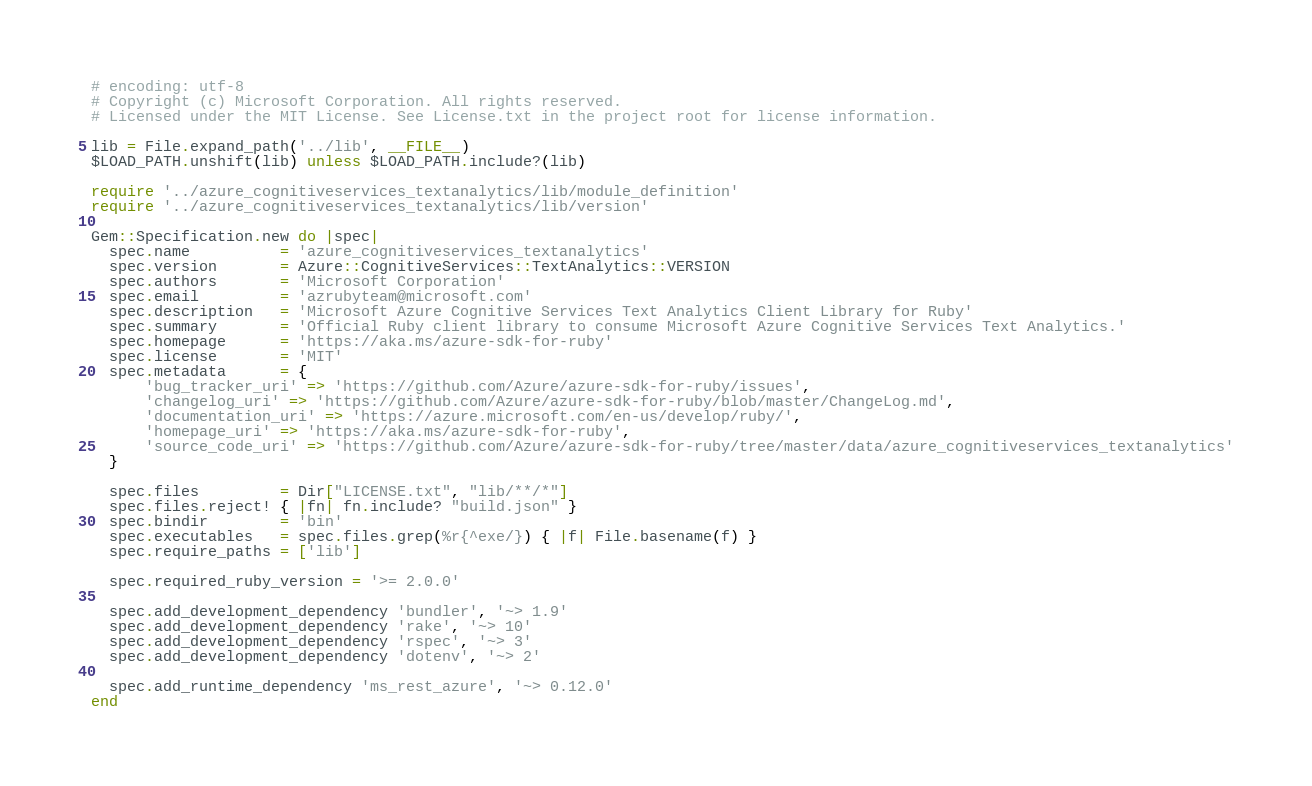Convert code to text. <code><loc_0><loc_0><loc_500><loc_500><_Ruby_># encoding: utf-8
# Copyright (c) Microsoft Corporation. All rights reserved.
# Licensed under the MIT License. See License.txt in the project root for license information.

lib = File.expand_path('../lib', __FILE__)
$LOAD_PATH.unshift(lib) unless $LOAD_PATH.include?(lib)

require '../azure_cognitiveservices_textanalytics/lib/module_definition'
require '../azure_cognitiveservices_textanalytics/lib/version'

Gem::Specification.new do |spec|
  spec.name          = 'azure_cognitiveservices_textanalytics'
  spec.version       = Azure::CognitiveServices::TextAnalytics::VERSION
  spec.authors       = 'Microsoft Corporation'
  spec.email         = 'azrubyteam@microsoft.com'
  spec.description   = 'Microsoft Azure Cognitive Services Text Analytics Client Library for Ruby'
  spec.summary       = 'Official Ruby client library to consume Microsoft Azure Cognitive Services Text Analytics.'
  spec.homepage      = 'https://aka.ms/azure-sdk-for-ruby'
  spec.license       = 'MIT'
  spec.metadata      = {
      'bug_tracker_uri' => 'https://github.com/Azure/azure-sdk-for-ruby/issues',
      'changelog_uri' => 'https://github.com/Azure/azure-sdk-for-ruby/blob/master/ChangeLog.md',
      'documentation_uri' => 'https://azure.microsoft.com/en-us/develop/ruby/',
      'homepage_uri' => 'https://aka.ms/azure-sdk-for-ruby',
      'source_code_uri' => 'https://github.com/Azure/azure-sdk-for-ruby/tree/master/data/azure_cognitiveservices_textanalytics'
  }

  spec.files         = Dir["LICENSE.txt", "lib/**/*"]
  spec.files.reject! { |fn| fn.include? "build.json" }
  spec.bindir        = 'bin'
  spec.executables   = spec.files.grep(%r{^exe/}) { |f| File.basename(f) }
  spec.require_paths = ['lib']

  spec.required_ruby_version = '>= 2.0.0'

  spec.add_development_dependency 'bundler', '~> 1.9'
  spec.add_development_dependency 'rake', '~> 10'
  spec.add_development_dependency 'rspec', '~> 3'
  spec.add_development_dependency 'dotenv', '~> 2'

  spec.add_runtime_dependency 'ms_rest_azure', '~> 0.12.0'
end
</code> 